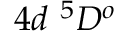<formula> <loc_0><loc_0><loc_500><loc_500>{ 4 d ^ { 5 } D ^ { o } }</formula> 